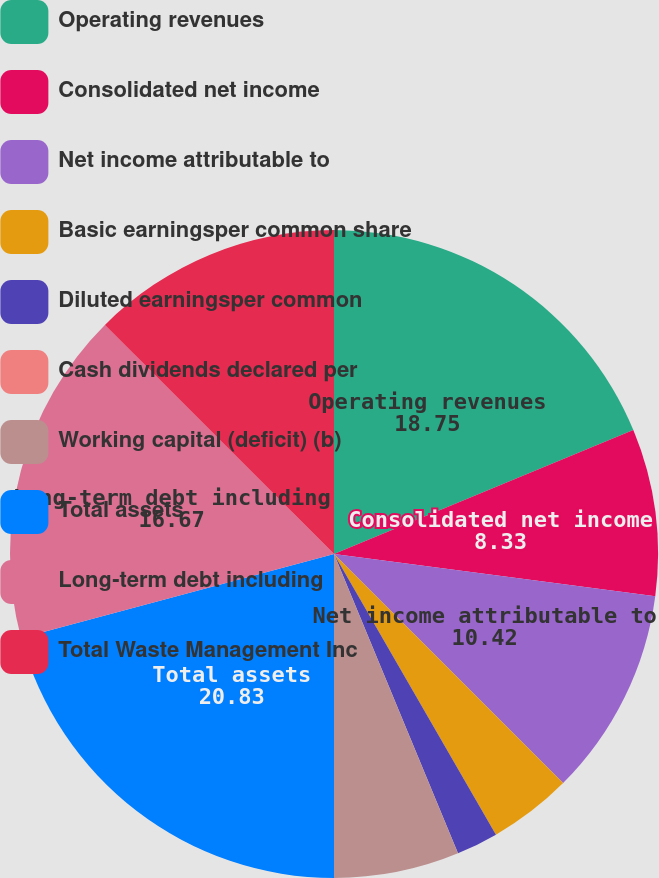Convert chart to OTSL. <chart><loc_0><loc_0><loc_500><loc_500><pie_chart><fcel>Operating revenues<fcel>Consolidated net income<fcel>Net income attributable to<fcel>Basic earningsper common share<fcel>Diluted earningsper common<fcel>Cash dividends declared per<fcel>Working capital (deficit) (b)<fcel>Total assets<fcel>Long-term debt including<fcel>Total Waste Management Inc<nl><fcel>18.75%<fcel>8.33%<fcel>10.42%<fcel>4.17%<fcel>2.08%<fcel>0.0%<fcel>6.25%<fcel>20.83%<fcel>16.67%<fcel>12.5%<nl></chart> 